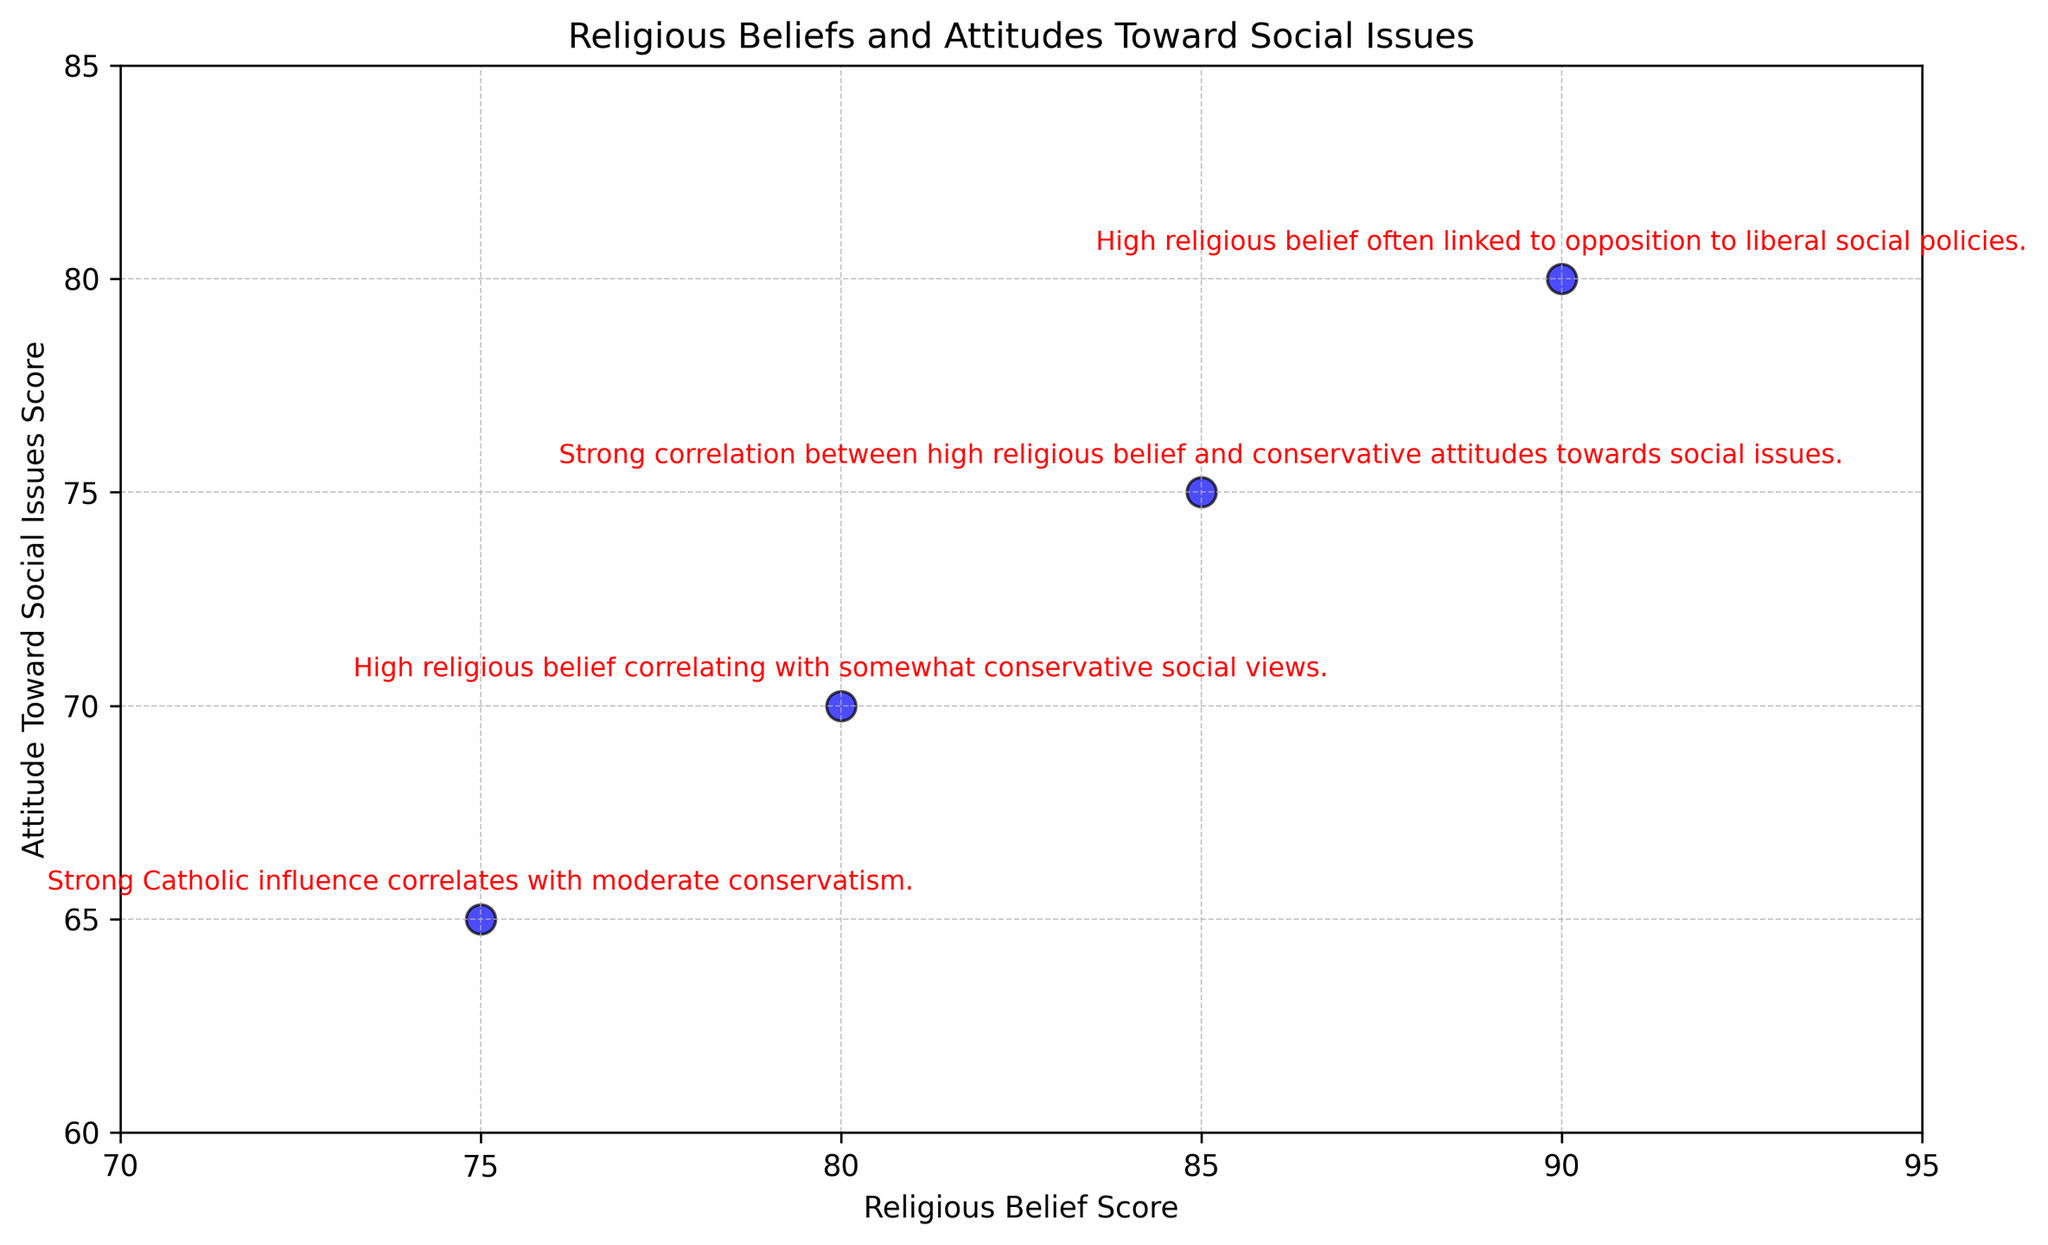What's the range of Religious Belief Scores shown in the figure? The Religious Belief Scores range from 75 (Italy) to 90 (Brazil), which is calculated by finding the difference between the highest and lowest scores.
Answer: 15 Which country has the highest Attitude Toward Social Issues Score? By observing the figure, Brazil has the highest score for Attitude Toward Social Issues at 80.
Answer: Brazil How does the Religious Belief Score of Italy compare with that of South Africa? Italy has a Religious Belief Score of 75, which is 5 points lower than South Africa's score of 80.
Answer: Lower What is the combined Religious Belief Score for USA and Brazil? The USA has a Religious Belief Score of 85 and Brazil has 90. Adding these together gives 85 + 90 = 175.
Answer: 175 What is the relationship between the Religious Belief Scores and the Attitude Toward Social Issues Scores as annotated in the figure? According to the annotations, a higher Religious Belief Score generally correlates with more conservative Attitudes Toward Social Issues.
Answer: Higher belief scores correlate with more conservatism What visual attribute is used to highlight the Key Insights in the figure? The Key Insights are highlighted using red color for the text annotations.
Answer: Red text annotations Are there more countries with a Religious Belief Score above 80 or below 80? Observing the Religious Belief Scores in the figure, three countries (USA, Brazil, and South Africa) have scores above 80 and only one (Italy) has below 80.
Answer: Above 80 What average score would you get by combining the Attitude Toward Social Issues Scores of all four countries? The scores are: USA (75), Brazil (80), Italy (65), and South Africa (70). Adding them up: 75 + 80 + 65 + 70 = 290. Dividing by 4 (number of countries): 290 / 4 = 72.5.
Answer: 72.5 Which country displays the largest difference between Religious Belief Score and Attitude Toward Social Issues Score? For each country: USA (85-75 = 10), Brazil (90-80 = 10), Italy (75-65 = 10), South Africa (80-70 = 10). All countries have the same difference of 10.
Answer: All equal (difference of 10) What countries show a strong correlation between high religious belief and conservative attitudes toward social issues according to the figure? The USA and Brazil, as indicated by the annotations, show a strong correlation between high religious belief and conservative attitudes toward social issues.
Answer: USA and Brazil 